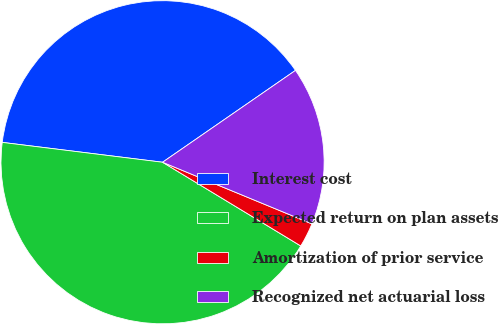<chart> <loc_0><loc_0><loc_500><loc_500><pie_chart><fcel>Interest cost<fcel>Expected return on plan assets<fcel>Amortization of prior service<fcel>Recognized net actuarial loss<nl><fcel>38.41%<fcel>43.29%<fcel>2.44%<fcel>15.85%<nl></chart> 